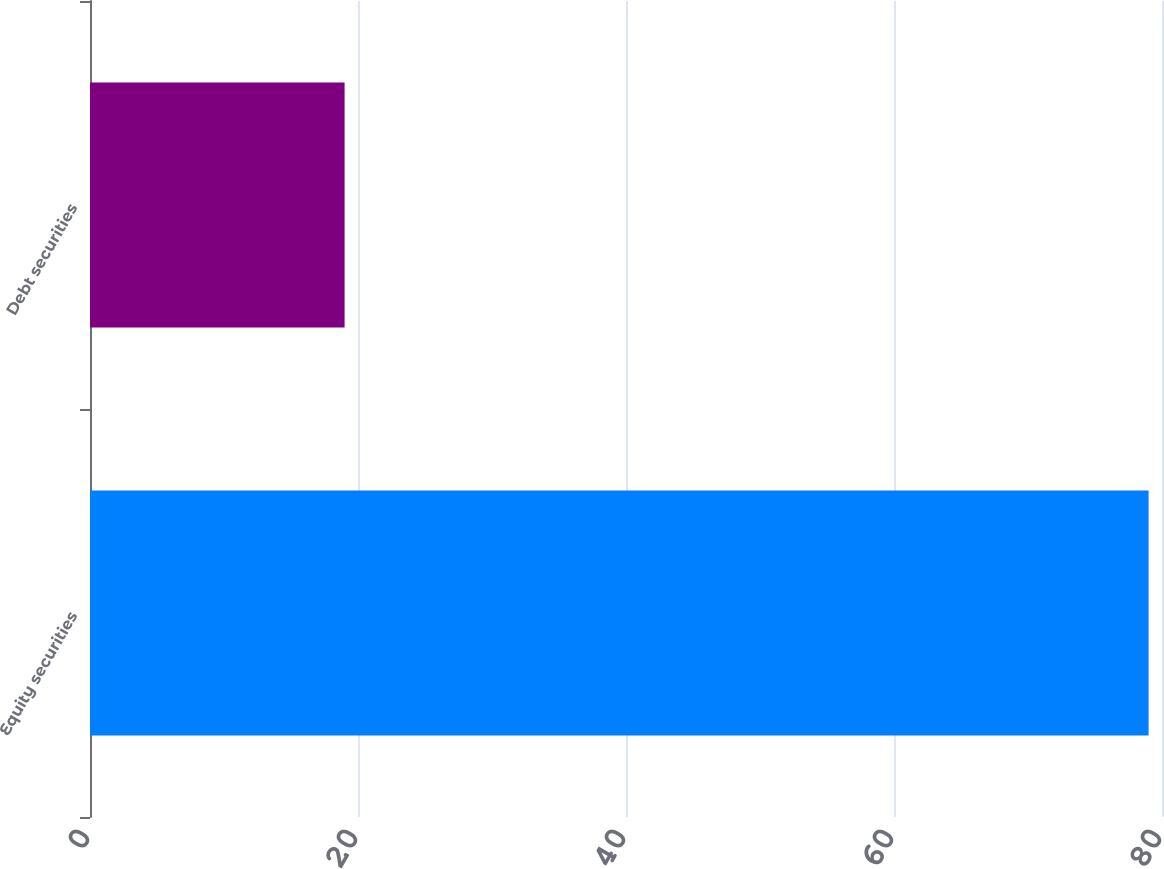<chart> <loc_0><loc_0><loc_500><loc_500><bar_chart><fcel>Equity securities<fcel>Debt securities<nl><fcel>79<fcel>19<nl></chart> 